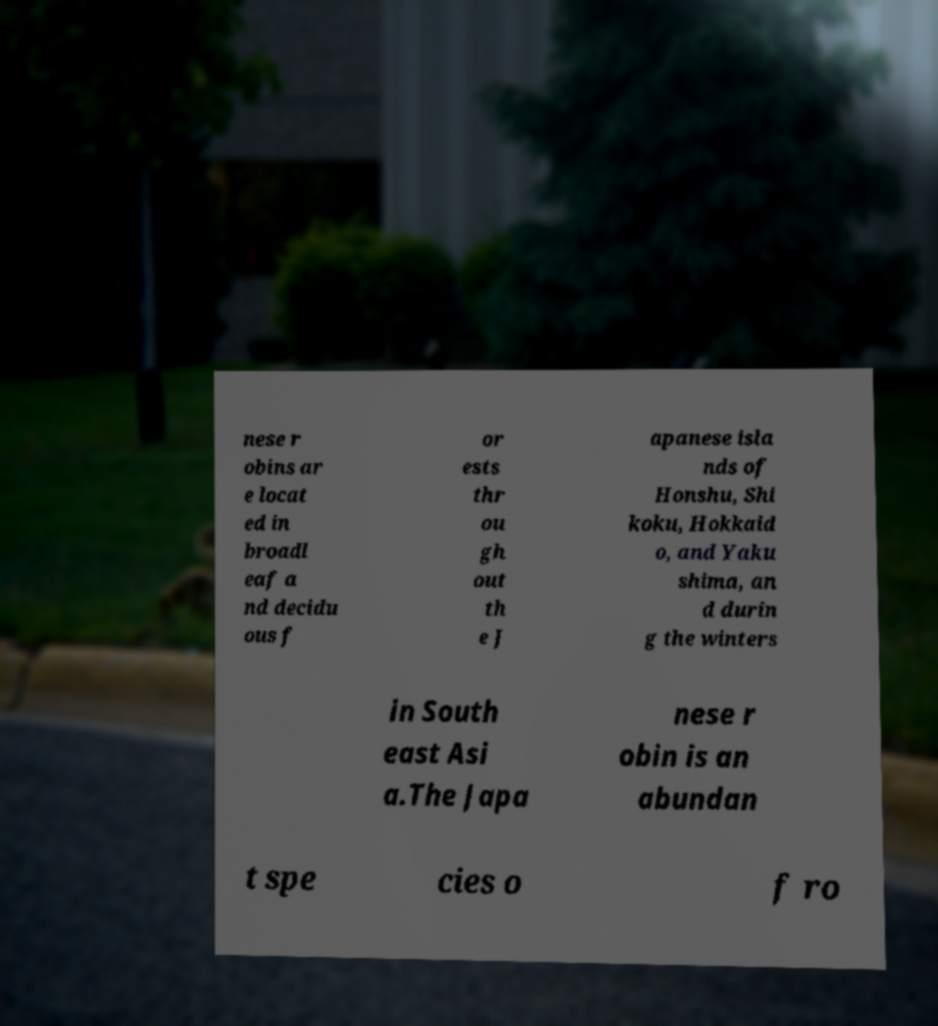Could you assist in decoding the text presented in this image and type it out clearly? nese r obins ar e locat ed in broadl eaf a nd decidu ous f or ests thr ou gh out th e J apanese isla nds of Honshu, Shi koku, Hokkaid o, and Yaku shima, an d durin g the winters in South east Asi a.The Japa nese r obin is an abundan t spe cies o f ro 